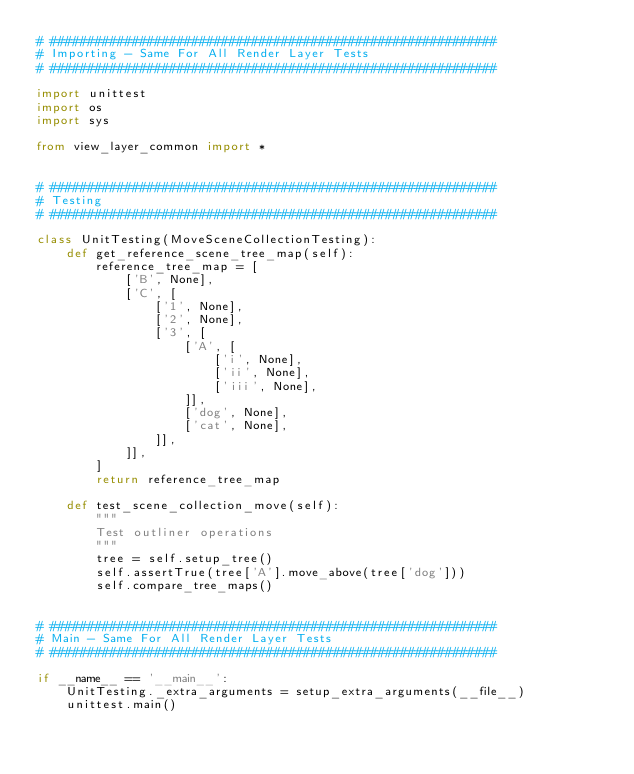Convert code to text. <code><loc_0><loc_0><loc_500><loc_500><_Python_># ############################################################
# Importing - Same For All Render Layer Tests
# ############################################################

import unittest
import os
import sys

from view_layer_common import *


# ############################################################
# Testing
# ############################################################

class UnitTesting(MoveSceneCollectionTesting):
    def get_reference_scene_tree_map(self):
        reference_tree_map = [
            ['B', None],
            ['C', [
                ['1', None],
                ['2', None],
                ['3', [
                    ['A', [
                        ['i', None],
                        ['ii', None],
                        ['iii', None],
                    ]],
                    ['dog', None],
                    ['cat', None],
                ]],
            ]],
        ]
        return reference_tree_map

    def test_scene_collection_move(self):
        """
        Test outliner operations
        """
        tree = self.setup_tree()
        self.assertTrue(tree['A'].move_above(tree['dog']))
        self.compare_tree_maps()


# ############################################################
# Main - Same For All Render Layer Tests
# ############################################################

if __name__ == '__main__':
    UnitTesting._extra_arguments = setup_extra_arguments(__file__)
    unittest.main()
</code> 